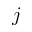<formula> <loc_0><loc_0><loc_500><loc_500>j</formula> 